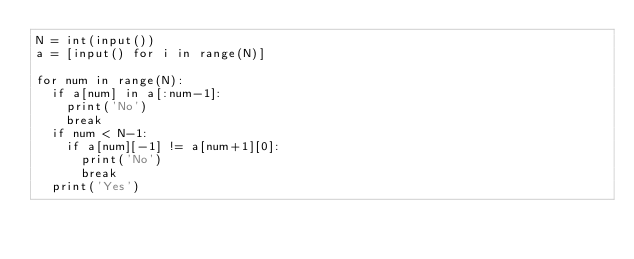Convert code to text. <code><loc_0><loc_0><loc_500><loc_500><_Python_>N = int(input())
a = [input() for i in range(N)]
 
for num in range(N):
  if a[num] in a[:num-1]:
    print('No')
    break
  if num < N-1:
    if a[num][-1] != a[num+1][0]:
    	print('No')
    	break
  print('Yes')</code> 